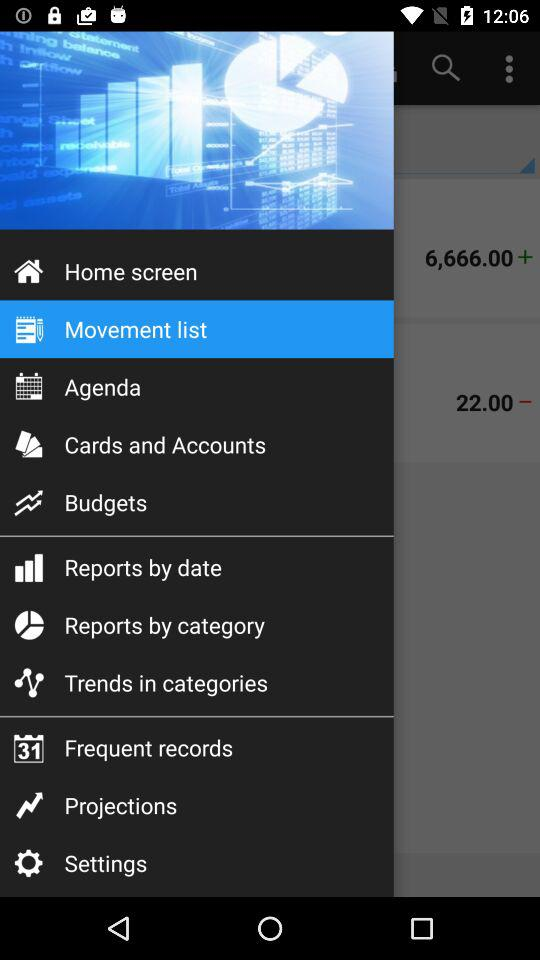When was the last screen refresh?
When the provided information is insufficient, respond with <no answer>. <no answer> 